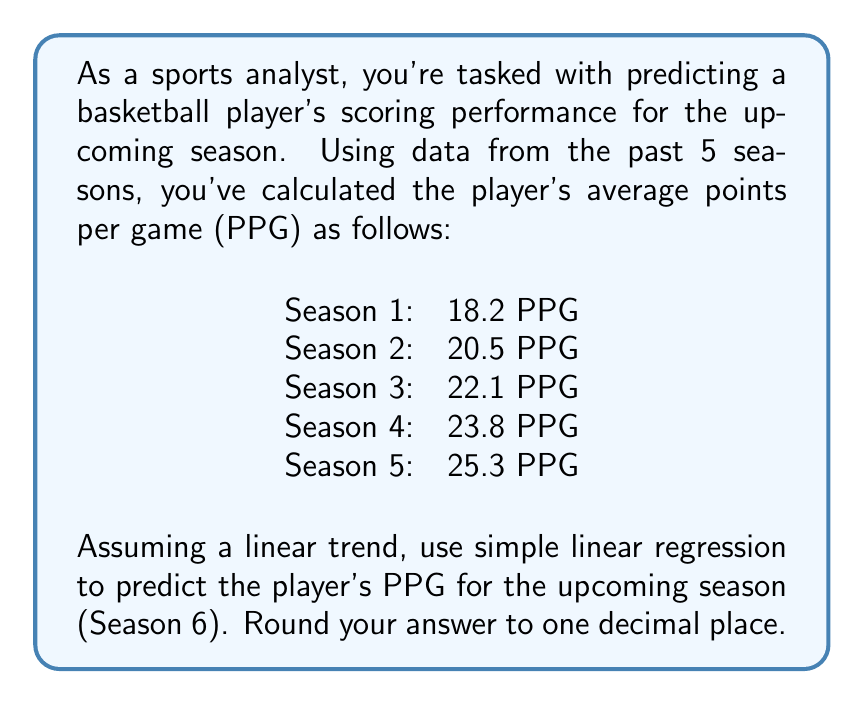Can you answer this question? To solve this problem using simple linear regression, we'll follow these steps:

1) Let x represent the season number (1-5) and y represent the PPG.

2) Calculate the means of x and y:
   $\bar{x} = \frac{1+2+3+4+5}{5} = 3$
   $\bar{y} = \frac{18.2+20.5+22.1+23.8+25.3}{5} = 21.98$

3) Calculate the slope (m) using the formula:
   $$m = \frac{\sum(x_i - \bar{x})(y_i - \bar{y})}{\sum(x_i - \bar{x})^2}$$

4) Compute the numerator and denominator:
   $\sum(x_i - \bar{x})(y_i - \bar{y}) = (-2)(-3.78) + (-1)(-1.48) + (0)(0.12) + (1)(1.82) + (2)(3.32) = 17.56$
   $\sum(x_i - \bar{x})^2 = (-2)^2 + (-1)^2 + (0)^2 + (1)^2 + (2)^2 = 10$

5) Calculate the slope:
   $m = \frac{17.56}{10} = 1.756$

6) Calculate the y-intercept (b) using the formula:
   $b = \bar{y} - m\bar{x} = 21.98 - (1.756)(3) = 16.712$

7) The linear regression equation is:
   $y = 1.756x + 16.712$

8) To predict Season 6 (x = 6), substitute into the equation:
   $y = 1.756(6) + 16.712 = 27.248$

9) Rounding to one decimal place: 27.2
Answer: 27.2 PPG 